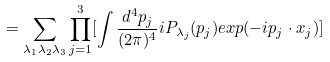Convert formula to latex. <formula><loc_0><loc_0><loc_500><loc_500>= \sum _ { \lambda _ { 1 } \lambda _ { 2 } \lambda _ { 3 } } \prod _ { j = 1 } ^ { 3 } [ \int \frac { d ^ { 4 } p _ { j } } { ( 2 \pi ) ^ { 4 } } i P _ { \lambda _ { j } } ( p _ { j } ) e x p ( - i p _ { j } \cdot x _ { j } ) ]</formula> 